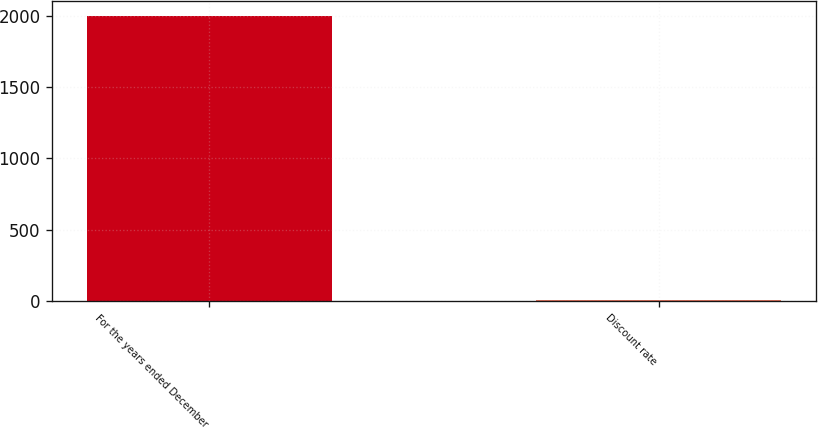Convert chart. <chart><loc_0><loc_0><loc_500><loc_500><bar_chart><fcel>For the years ended December<fcel>Discount rate<nl><fcel>2004<fcel>6<nl></chart> 